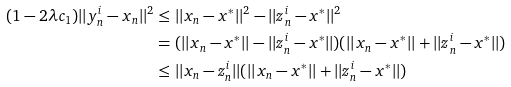Convert formula to latex. <formula><loc_0><loc_0><loc_500><loc_500>( 1 - 2 \lambda c _ { 1 } ) | | y _ { n } ^ { i } - x _ { n } | | ^ { 2 } & \leq | | x _ { n } - x ^ { * } | | ^ { 2 } - | | z _ { n } ^ { i } - x ^ { * } | | ^ { 2 } \\ & = ( | | x _ { n } - x ^ { * } | | - | | z ^ { i } _ { n } - x ^ { * } | | ) ( | | x _ { n } - x ^ { * } | | + | | z ^ { i } _ { n } - x ^ { * } | | ) \\ & \leq | | x _ { n } - z ^ { i } _ { n } | | ( | | x _ { n } - x ^ { * } | | + | | z ^ { i } _ { n } - x ^ { * } | | )</formula> 